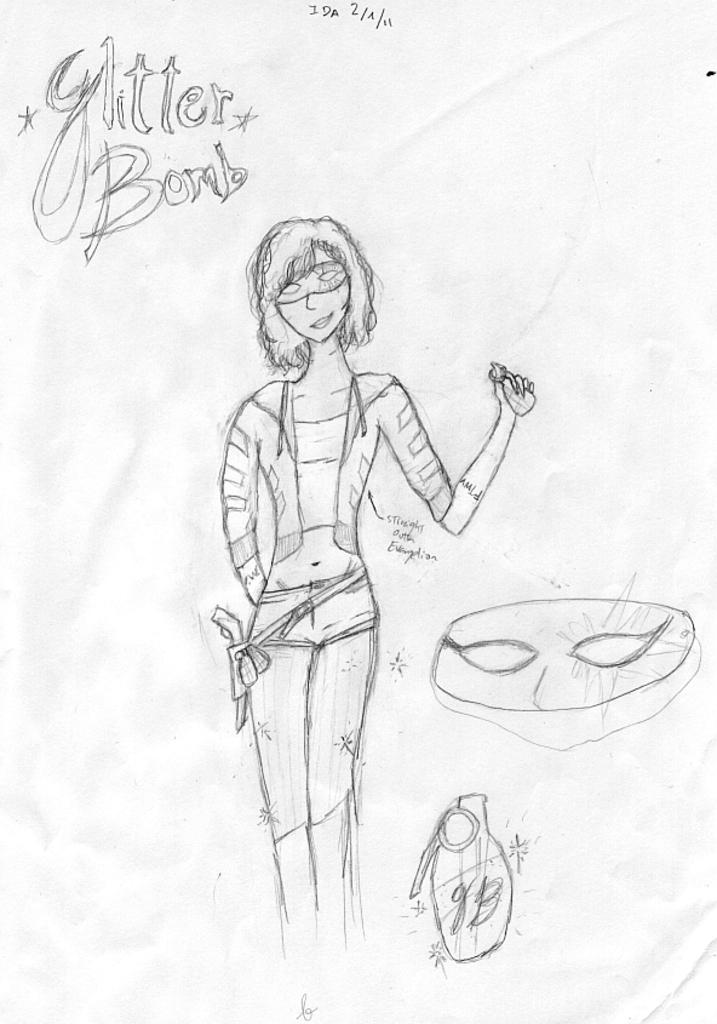What is depicted on the paper in the image? There is a drawing of a lady on the paper. What is the lady in the drawing wearing on her face? The lady in the drawing is wearing a mask on her face. What else can be seen in the drawing besides the lady? There are other things in the drawing. Is there any text on the paper? Yes, there is writing on the paper. What type of shirt is the lady wearing in the drawing? The lady in the drawing is not wearing a shirt; she is wearing a mask on her face. How many carts are visible in the drawing? There are no carts visible in the drawing; the image only features a drawing of a lady and some writing on the paper. 